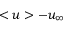Convert formula to latex. <formula><loc_0><loc_0><loc_500><loc_500>< u > - u _ { \infty }</formula> 